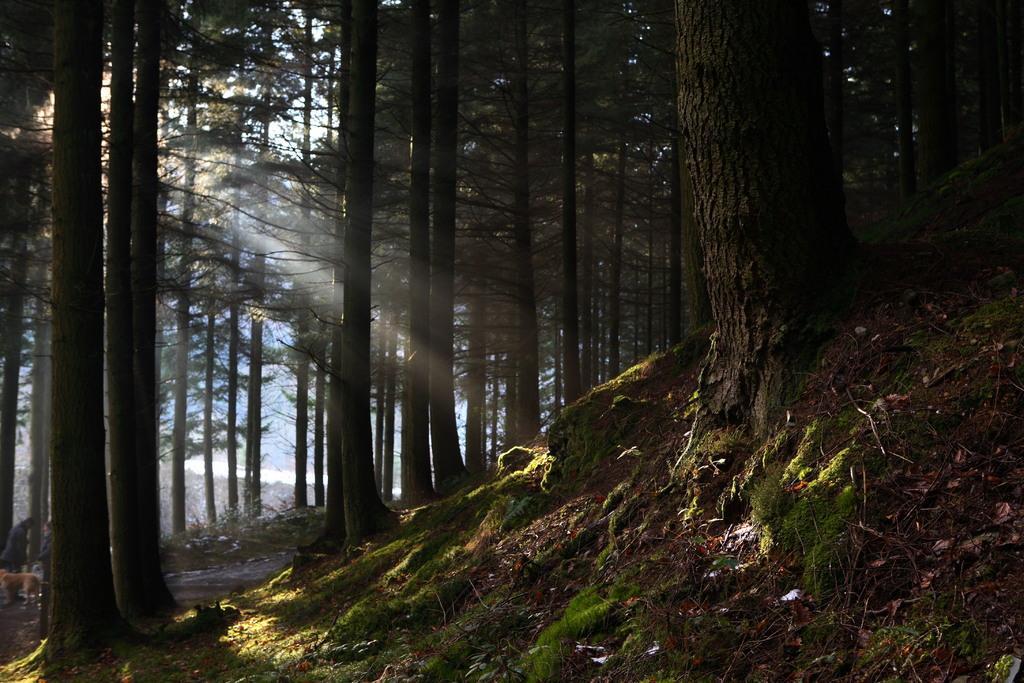How would you summarize this image in a sentence or two? In this image we can see many trees and grass on the ground. 